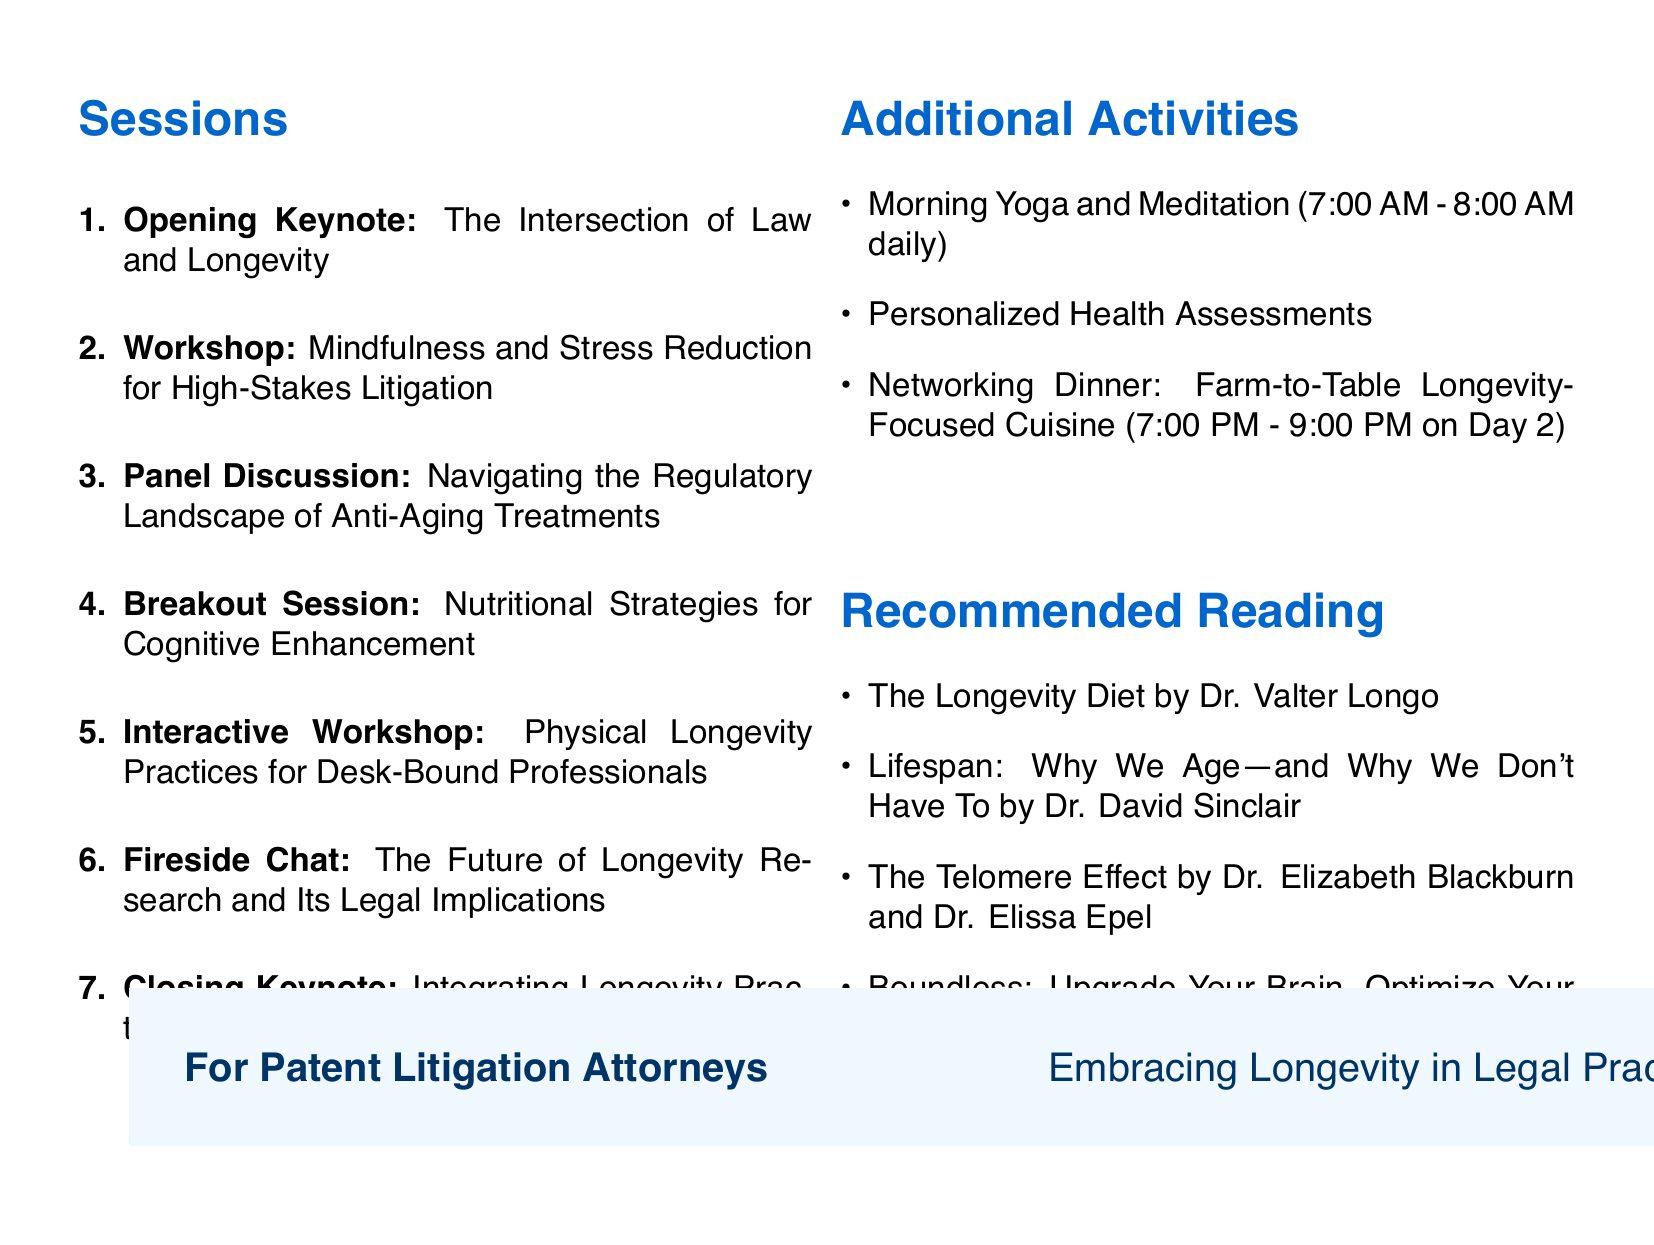What are the dates of the retreat? The document states the retreat will occur from September 15 to 17, 2023.
Answer: September 15-17, 2023 Who is the speaker for the opening keynote session? The opening keynote session features Dr. David Sinclair, a Professor of Genetics.
Answer: Dr. David Sinclair What is the duration of the panel discussion? The duration for the panel discussion is specified as 90 minutes in the document.
Answer: 90 minutes How many panelists are participating in the panel discussion? The document lists three panelists participating in the panel discussion.
Answer: Three What is the title of the closing keynote session? The title of the closing keynote session is clearly stated in the document.
Answer: Integrating Longevity Practices into High-Performance Legal Careers What type of additional activities are offered daily in the morning? The agenda mentions a specific activity that happens every morning.
Answer: Morning Yoga and Meditation Who is the chef for the networking dinner? The document specifies the name of the chef responsible for the networking dinner event.
Answer: Dan Barber What is the main theme of the retreat? The theme reflects a focus on promoting health and wellness practices related to longevity for a specific audience in the document.
Answer: Longevity-Focused Health and Wellness Retreat What is the duration of the interactive workshop? The document states the duration of the interactive workshop with a clear number.
Answer: 90 minutes 